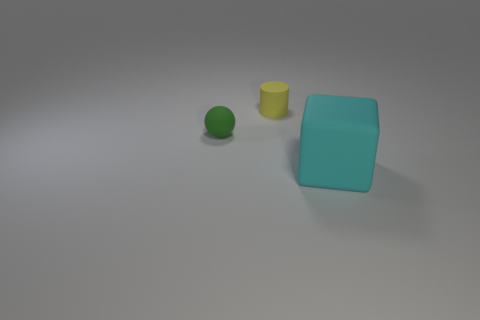Subtract all red cylinders. Subtract all yellow blocks. How many cylinders are left? 1 Add 3 yellow cylinders. How many objects exist? 6 Subtract all balls. How many objects are left? 2 Subtract all tiny brown cubes. Subtract all large cyan cubes. How many objects are left? 2 Add 1 green rubber spheres. How many green rubber spheres are left? 2 Add 1 yellow matte cylinders. How many yellow matte cylinders exist? 2 Subtract 0 purple spheres. How many objects are left? 3 